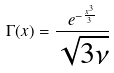<formula> <loc_0><loc_0><loc_500><loc_500>\Gamma ( x ) = \frac { e ^ { - \frac { x ^ { 3 } } { 3 } } } { \sqrt { 3 \nu } }</formula> 